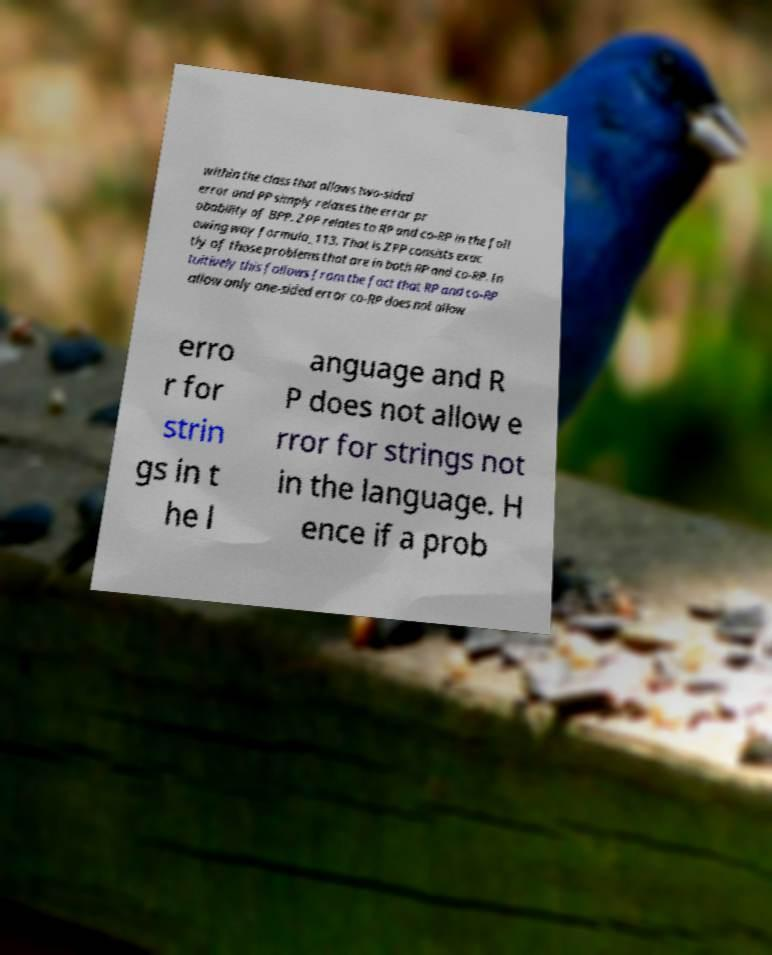Please identify and transcribe the text found in this image. within the class that allows two-sided error and PP simply relaxes the error pr obability of BPP. ZPP relates to RP and co-RP in the foll owing way formula_113. That is ZPP consists exac tly of those problems that are in both RP and co-RP. In tuitively this follows from the fact that RP and co-RP allow only one-sided error co-RP does not allow erro r for strin gs in t he l anguage and R P does not allow e rror for strings not in the language. H ence if a prob 